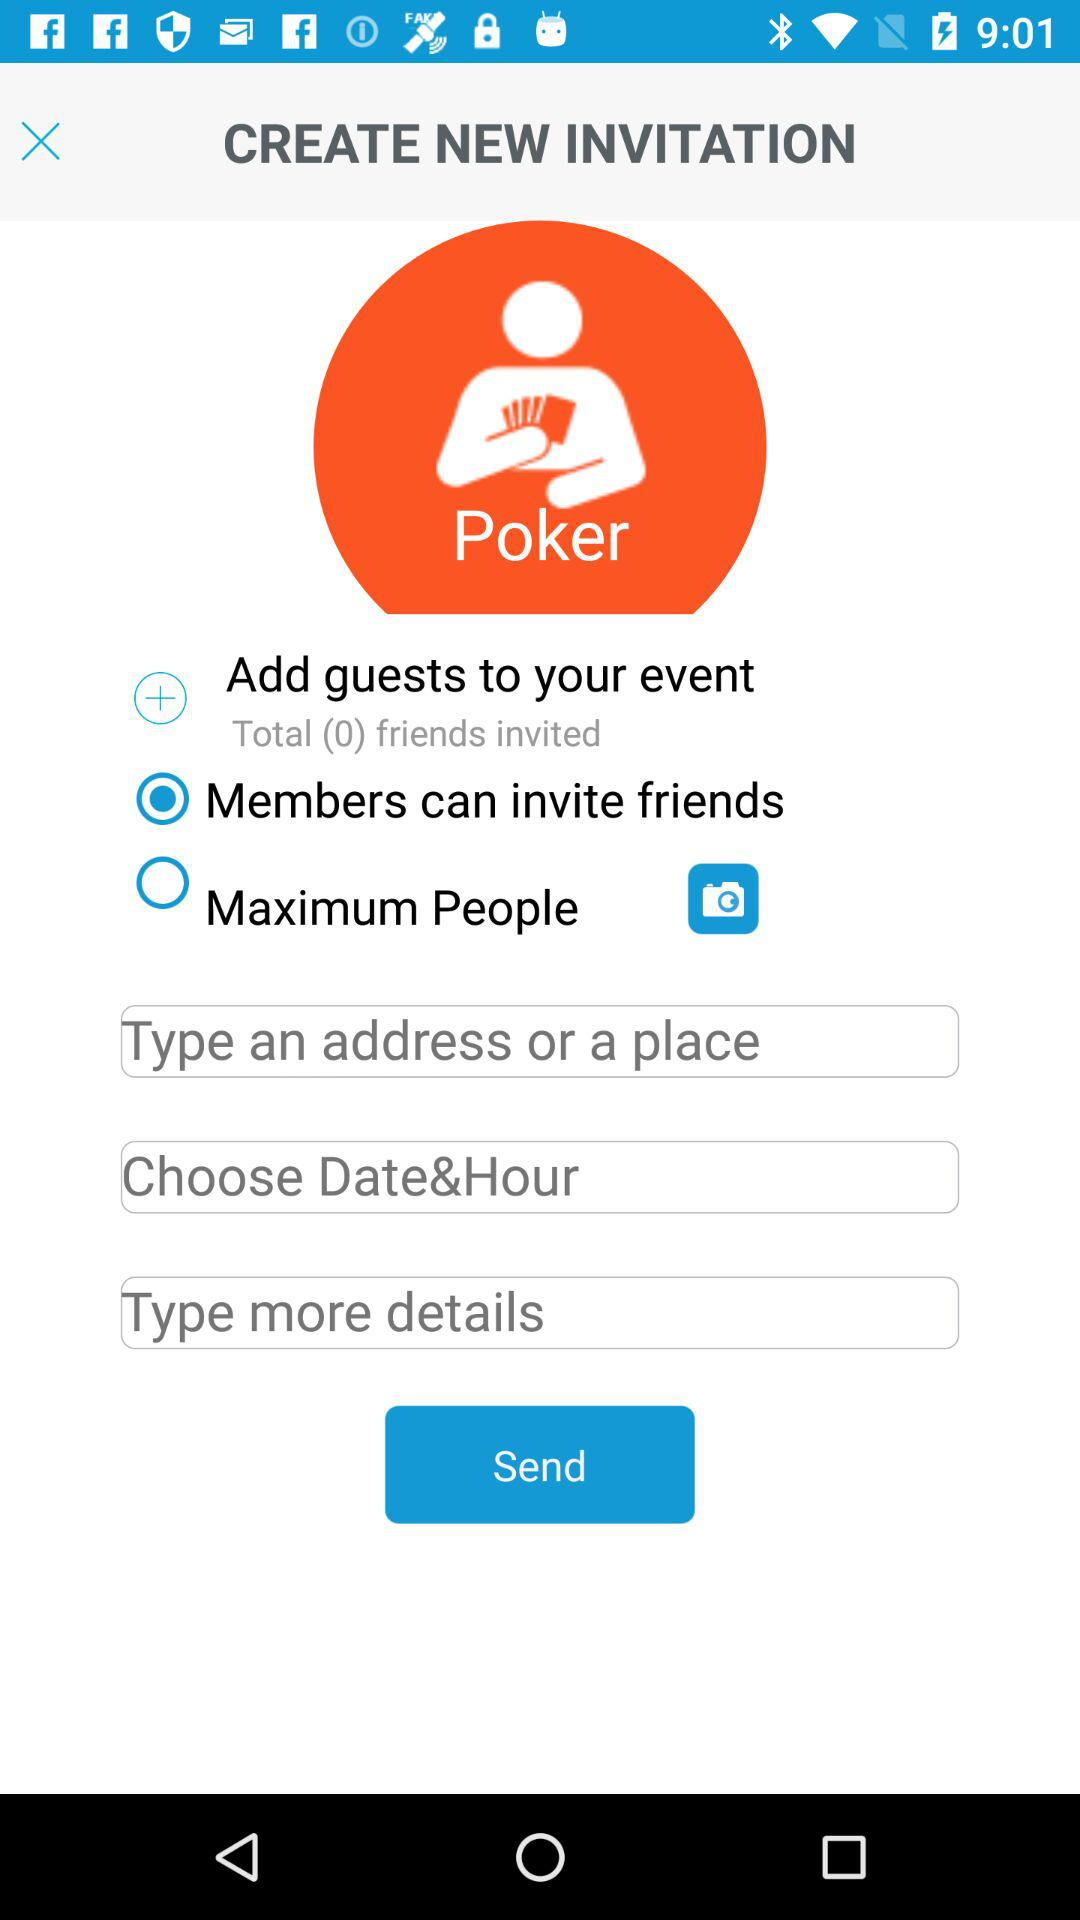How many total friends are invited? There are 0 friends invited. 